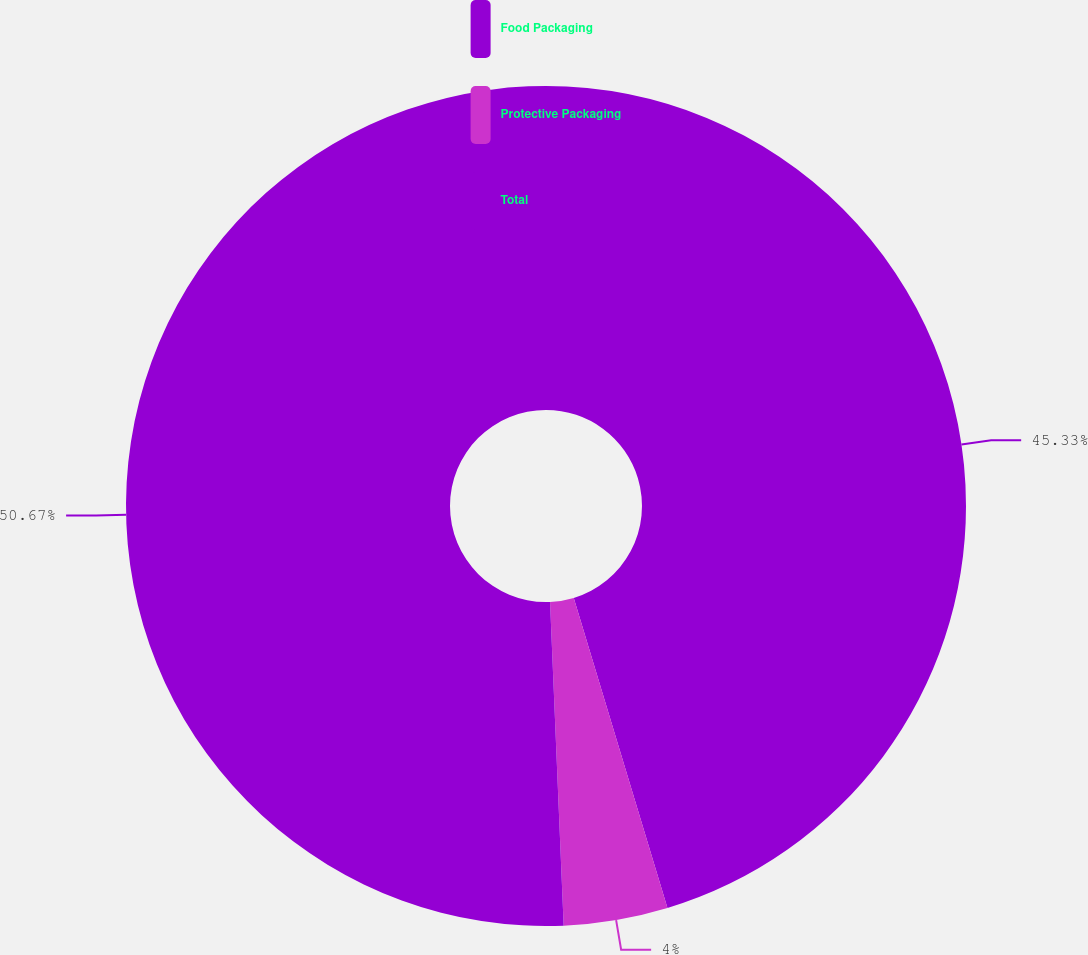<chart> <loc_0><loc_0><loc_500><loc_500><pie_chart><fcel>Food Packaging<fcel>Protective Packaging<fcel>Total<nl><fcel>45.33%<fcel>4.0%<fcel>50.67%<nl></chart> 